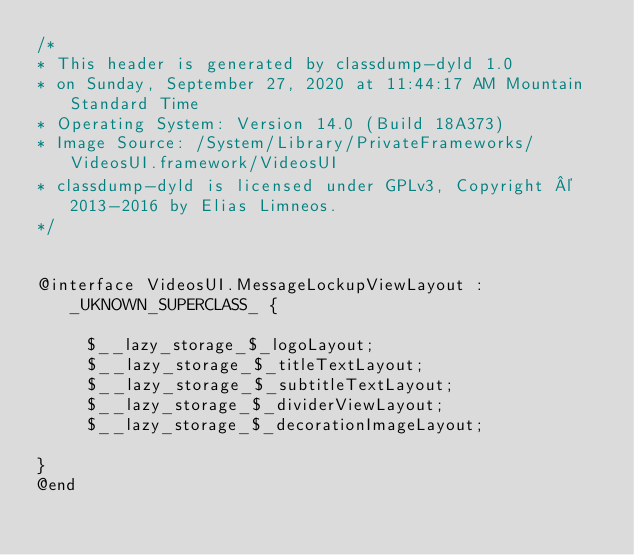Convert code to text. <code><loc_0><loc_0><loc_500><loc_500><_C_>/*
* This header is generated by classdump-dyld 1.0
* on Sunday, September 27, 2020 at 11:44:17 AM Mountain Standard Time
* Operating System: Version 14.0 (Build 18A373)
* Image Source: /System/Library/PrivateFrameworks/VideosUI.framework/VideosUI
* classdump-dyld is licensed under GPLv3, Copyright © 2013-2016 by Elias Limneos.
*/


@interface VideosUI.MessageLockupViewLayout : _UKNOWN_SUPERCLASS_ {

	 $__lazy_storage_$_logoLayout;
	 $__lazy_storage_$_titleTextLayout;
	 $__lazy_storage_$_subtitleTextLayout;
	 $__lazy_storage_$_dividerViewLayout;
	 $__lazy_storage_$_decorationImageLayout;

}
@end

</code> 